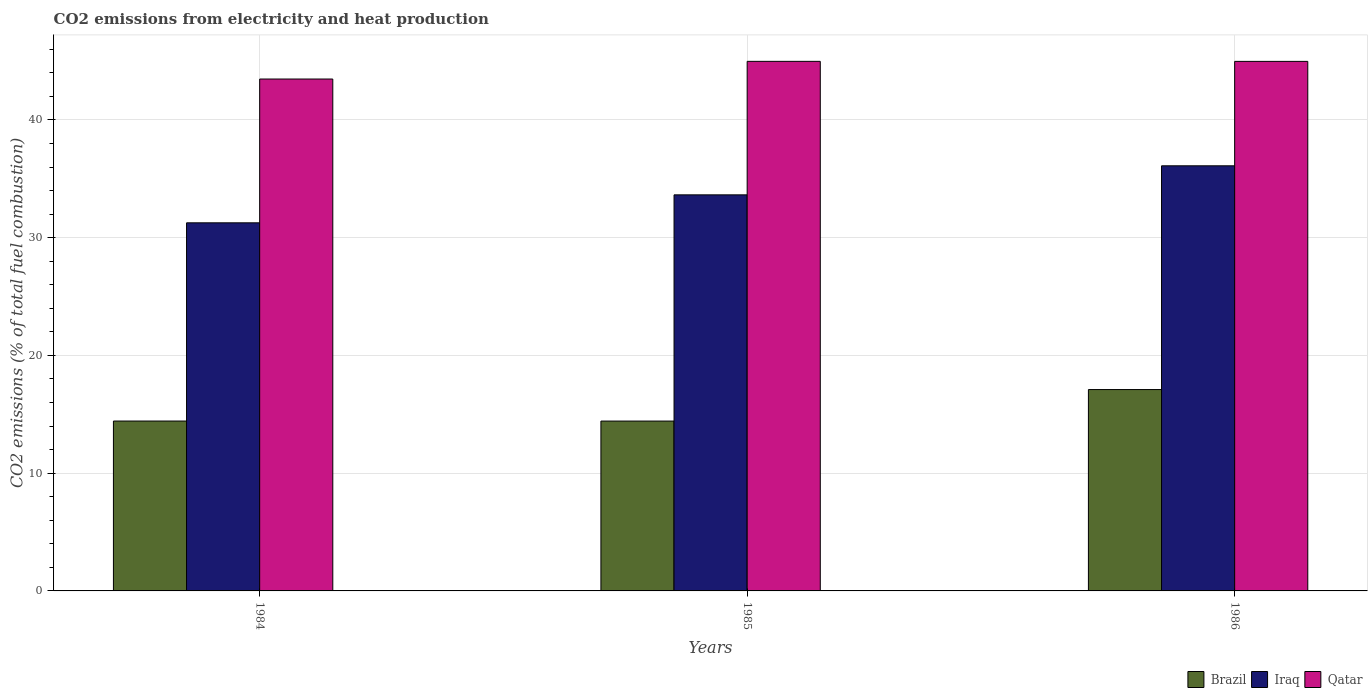How many different coloured bars are there?
Give a very brief answer. 3. Are the number of bars on each tick of the X-axis equal?
Your answer should be very brief. Yes. How many bars are there on the 2nd tick from the left?
Offer a terse response. 3. How many bars are there on the 1st tick from the right?
Make the answer very short. 3. What is the label of the 1st group of bars from the left?
Provide a succinct answer. 1984. What is the amount of CO2 emitted in Qatar in 1986?
Provide a short and direct response. 44.98. Across all years, what is the maximum amount of CO2 emitted in Qatar?
Your answer should be very brief. 44.98. Across all years, what is the minimum amount of CO2 emitted in Brazil?
Make the answer very short. 14.43. What is the total amount of CO2 emitted in Brazil in the graph?
Make the answer very short. 45.96. What is the difference between the amount of CO2 emitted in Iraq in 1985 and that in 1986?
Your answer should be very brief. -2.47. What is the difference between the amount of CO2 emitted in Brazil in 1986 and the amount of CO2 emitted in Iraq in 1984?
Provide a succinct answer. -14.16. What is the average amount of CO2 emitted in Iraq per year?
Give a very brief answer. 33.67. In the year 1986, what is the difference between the amount of CO2 emitted in Qatar and amount of CO2 emitted in Iraq?
Provide a short and direct response. 8.87. In how many years, is the amount of CO2 emitted in Brazil greater than 32 %?
Your response must be concise. 0. What is the ratio of the amount of CO2 emitted in Brazil in 1985 to that in 1986?
Provide a succinct answer. 0.84. Is the amount of CO2 emitted in Iraq in 1985 less than that in 1986?
Your response must be concise. Yes. Is the difference between the amount of CO2 emitted in Qatar in 1984 and 1985 greater than the difference between the amount of CO2 emitted in Iraq in 1984 and 1985?
Your answer should be very brief. Yes. What is the difference between the highest and the second highest amount of CO2 emitted in Brazil?
Give a very brief answer. 2.67. What is the difference between the highest and the lowest amount of CO2 emitted in Iraq?
Your response must be concise. 4.84. What does the 2nd bar from the left in 1986 represents?
Your response must be concise. Iraq. Is it the case that in every year, the sum of the amount of CO2 emitted in Brazil and amount of CO2 emitted in Iraq is greater than the amount of CO2 emitted in Qatar?
Your answer should be very brief. Yes. Are all the bars in the graph horizontal?
Give a very brief answer. No. Does the graph contain grids?
Your answer should be compact. Yes. Where does the legend appear in the graph?
Provide a short and direct response. Bottom right. How are the legend labels stacked?
Provide a short and direct response. Horizontal. What is the title of the graph?
Provide a short and direct response. CO2 emissions from electricity and heat production. What is the label or title of the Y-axis?
Provide a short and direct response. CO2 emissions (% of total fuel combustion). What is the CO2 emissions (% of total fuel combustion) in Brazil in 1984?
Make the answer very short. 14.43. What is the CO2 emissions (% of total fuel combustion) of Iraq in 1984?
Your answer should be very brief. 31.26. What is the CO2 emissions (% of total fuel combustion) in Qatar in 1984?
Keep it short and to the point. 43.48. What is the CO2 emissions (% of total fuel combustion) of Brazil in 1985?
Make the answer very short. 14.43. What is the CO2 emissions (% of total fuel combustion) in Iraq in 1985?
Your answer should be compact. 33.64. What is the CO2 emissions (% of total fuel combustion) in Qatar in 1985?
Offer a terse response. 44.98. What is the CO2 emissions (% of total fuel combustion) of Brazil in 1986?
Ensure brevity in your answer.  17.1. What is the CO2 emissions (% of total fuel combustion) in Iraq in 1986?
Your response must be concise. 36.11. What is the CO2 emissions (% of total fuel combustion) in Qatar in 1986?
Keep it short and to the point. 44.98. Across all years, what is the maximum CO2 emissions (% of total fuel combustion) in Brazil?
Your answer should be very brief. 17.1. Across all years, what is the maximum CO2 emissions (% of total fuel combustion) in Iraq?
Ensure brevity in your answer.  36.11. Across all years, what is the maximum CO2 emissions (% of total fuel combustion) in Qatar?
Your response must be concise. 44.98. Across all years, what is the minimum CO2 emissions (% of total fuel combustion) of Brazil?
Ensure brevity in your answer.  14.43. Across all years, what is the minimum CO2 emissions (% of total fuel combustion) in Iraq?
Make the answer very short. 31.26. Across all years, what is the minimum CO2 emissions (% of total fuel combustion) of Qatar?
Ensure brevity in your answer.  43.48. What is the total CO2 emissions (% of total fuel combustion) of Brazil in the graph?
Ensure brevity in your answer.  45.96. What is the total CO2 emissions (% of total fuel combustion) in Iraq in the graph?
Your answer should be compact. 101.01. What is the total CO2 emissions (% of total fuel combustion) in Qatar in the graph?
Give a very brief answer. 133.44. What is the difference between the CO2 emissions (% of total fuel combustion) in Brazil in 1984 and that in 1985?
Offer a very short reply. 0. What is the difference between the CO2 emissions (% of total fuel combustion) of Iraq in 1984 and that in 1985?
Ensure brevity in your answer.  -2.38. What is the difference between the CO2 emissions (% of total fuel combustion) of Qatar in 1984 and that in 1985?
Give a very brief answer. -1.5. What is the difference between the CO2 emissions (% of total fuel combustion) of Brazil in 1984 and that in 1986?
Make the answer very short. -2.67. What is the difference between the CO2 emissions (% of total fuel combustion) of Iraq in 1984 and that in 1986?
Ensure brevity in your answer.  -4.84. What is the difference between the CO2 emissions (% of total fuel combustion) in Qatar in 1984 and that in 1986?
Offer a terse response. -1.5. What is the difference between the CO2 emissions (% of total fuel combustion) in Brazil in 1985 and that in 1986?
Your response must be concise. -2.68. What is the difference between the CO2 emissions (% of total fuel combustion) of Iraq in 1985 and that in 1986?
Your answer should be very brief. -2.47. What is the difference between the CO2 emissions (% of total fuel combustion) in Qatar in 1985 and that in 1986?
Your answer should be compact. 0. What is the difference between the CO2 emissions (% of total fuel combustion) of Brazil in 1984 and the CO2 emissions (% of total fuel combustion) of Iraq in 1985?
Provide a short and direct response. -19.21. What is the difference between the CO2 emissions (% of total fuel combustion) of Brazil in 1984 and the CO2 emissions (% of total fuel combustion) of Qatar in 1985?
Provide a short and direct response. -30.55. What is the difference between the CO2 emissions (% of total fuel combustion) in Iraq in 1984 and the CO2 emissions (% of total fuel combustion) in Qatar in 1985?
Your response must be concise. -13.71. What is the difference between the CO2 emissions (% of total fuel combustion) of Brazil in 1984 and the CO2 emissions (% of total fuel combustion) of Iraq in 1986?
Your response must be concise. -21.68. What is the difference between the CO2 emissions (% of total fuel combustion) of Brazil in 1984 and the CO2 emissions (% of total fuel combustion) of Qatar in 1986?
Provide a succinct answer. -30.55. What is the difference between the CO2 emissions (% of total fuel combustion) in Iraq in 1984 and the CO2 emissions (% of total fuel combustion) in Qatar in 1986?
Ensure brevity in your answer.  -13.71. What is the difference between the CO2 emissions (% of total fuel combustion) in Brazil in 1985 and the CO2 emissions (% of total fuel combustion) in Iraq in 1986?
Provide a succinct answer. -21.68. What is the difference between the CO2 emissions (% of total fuel combustion) in Brazil in 1985 and the CO2 emissions (% of total fuel combustion) in Qatar in 1986?
Make the answer very short. -30.55. What is the difference between the CO2 emissions (% of total fuel combustion) of Iraq in 1985 and the CO2 emissions (% of total fuel combustion) of Qatar in 1986?
Keep it short and to the point. -11.34. What is the average CO2 emissions (% of total fuel combustion) in Brazil per year?
Offer a very short reply. 15.32. What is the average CO2 emissions (% of total fuel combustion) in Iraq per year?
Provide a succinct answer. 33.67. What is the average CO2 emissions (% of total fuel combustion) in Qatar per year?
Give a very brief answer. 44.48. In the year 1984, what is the difference between the CO2 emissions (% of total fuel combustion) in Brazil and CO2 emissions (% of total fuel combustion) in Iraq?
Offer a terse response. -16.84. In the year 1984, what is the difference between the CO2 emissions (% of total fuel combustion) of Brazil and CO2 emissions (% of total fuel combustion) of Qatar?
Give a very brief answer. -29.05. In the year 1984, what is the difference between the CO2 emissions (% of total fuel combustion) in Iraq and CO2 emissions (% of total fuel combustion) in Qatar?
Ensure brevity in your answer.  -12.21. In the year 1985, what is the difference between the CO2 emissions (% of total fuel combustion) in Brazil and CO2 emissions (% of total fuel combustion) in Iraq?
Offer a very short reply. -19.21. In the year 1985, what is the difference between the CO2 emissions (% of total fuel combustion) of Brazil and CO2 emissions (% of total fuel combustion) of Qatar?
Offer a very short reply. -30.55. In the year 1985, what is the difference between the CO2 emissions (% of total fuel combustion) of Iraq and CO2 emissions (% of total fuel combustion) of Qatar?
Offer a terse response. -11.34. In the year 1986, what is the difference between the CO2 emissions (% of total fuel combustion) of Brazil and CO2 emissions (% of total fuel combustion) of Iraq?
Offer a terse response. -19. In the year 1986, what is the difference between the CO2 emissions (% of total fuel combustion) in Brazil and CO2 emissions (% of total fuel combustion) in Qatar?
Ensure brevity in your answer.  -27.87. In the year 1986, what is the difference between the CO2 emissions (% of total fuel combustion) of Iraq and CO2 emissions (% of total fuel combustion) of Qatar?
Keep it short and to the point. -8.87. What is the ratio of the CO2 emissions (% of total fuel combustion) of Iraq in 1984 to that in 1985?
Your response must be concise. 0.93. What is the ratio of the CO2 emissions (% of total fuel combustion) of Qatar in 1984 to that in 1985?
Ensure brevity in your answer.  0.97. What is the ratio of the CO2 emissions (% of total fuel combustion) of Brazil in 1984 to that in 1986?
Ensure brevity in your answer.  0.84. What is the ratio of the CO2 emissions (% of total fuel combustion) of Iraq in 1984 to that in 1986?
Provide a short and direct response. 0.87. What is the ratio of the CO2 emissions (% of total fuel combustion) in Qatar in 1984 to that in 1986?
Give a very brief answer. 0.97. What is the ratio of the CO2 emissions (% of total fuel combustion) in Brazil in 1985 to that in 1986?
Provide a short and direct response. 0.84. What is the ratio of the CO2 emissions (% of total fuel combustion) of Iraq in 1985 to that in 1986?
Offer a very short reply. 0.93. What is the ratio of the CO2 emissions (% of total fuel combustion) in Qatar in 1985 to that in 1986?
Ensure brevity in your answer.  1. What is the difference between the highest and the second highest CO2 emissions (% of total fuel combustion) in Brazil?
Your answer should be compact. 2.67. What is the difference between the highest and the second highest CO2 emissions (% of total fuel combustion) of Iraq?
Your answer should be very brief. 2.47. What is the difference between the highest and the second highest CO2 emissions (% of total fuel combustion) of Qatar?
Offer a terse response. 0. What is the difference between the highest and the lowest CO2 emissions (% of total fuel combustion) in Brazil?
Offer a very short reply. 2.68. What is the difference between the highest and the lowest CO2 emissions (% of total fuel combustion) of Iraq?
Your response must be concise. 4.84. What is the difference between the highest and the lowest CO2 emissions (% of total fuel combustion) of Qatar?
Offer a terse response. 1.5. 